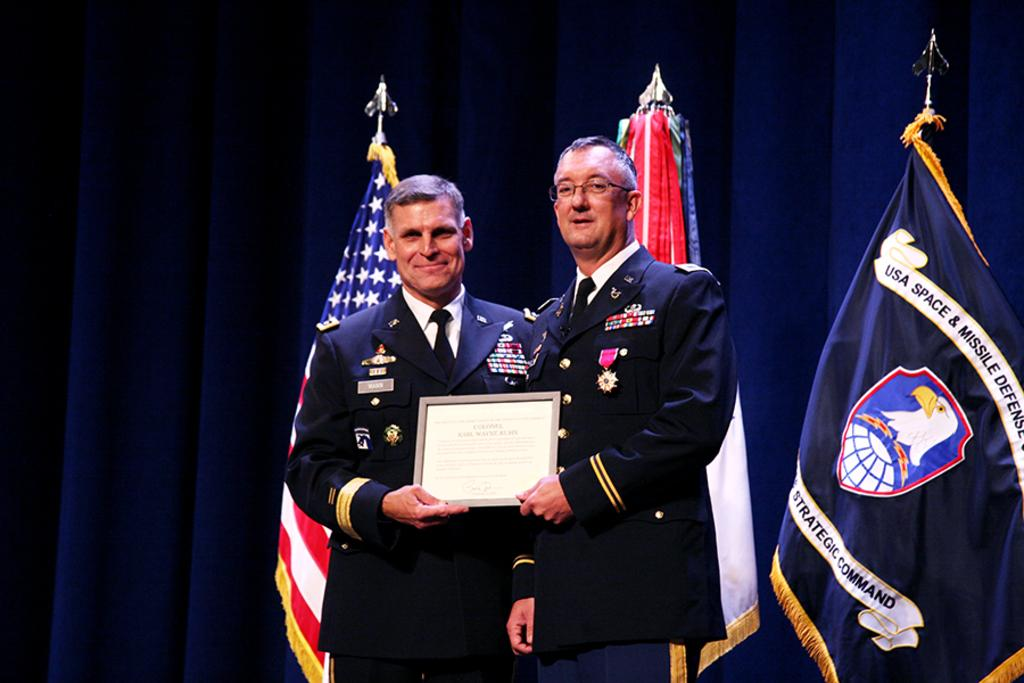<image>
Give a short and clear explanation of the subsequent image. Two military officers are holding a plaque in front of a flag for the USA Space and Missile Defense team. 